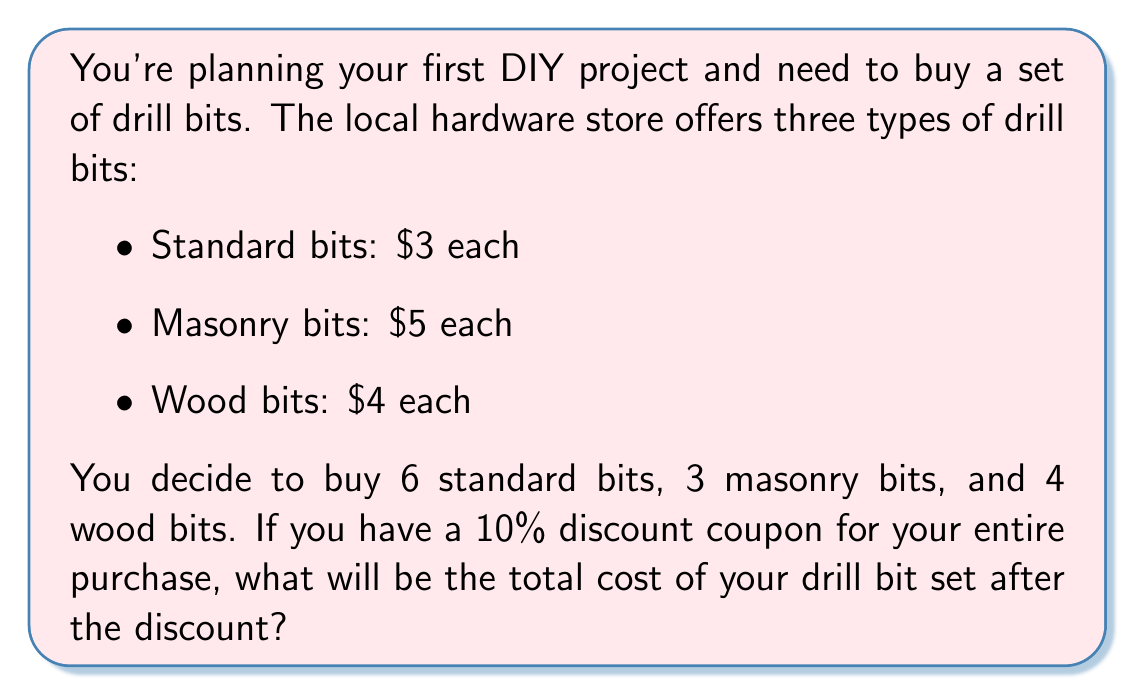Solve this math problem. Let's approach this step-by-step:

1) First, let's calculate the cost of each type of drill bit:
   - Standard bits: $6 \times $3 = $18$
   - Masonry bits: $3 \times $5 = $15$
   - Wood bits: $4 \times $4 = $16$

2) Now, let's add up the total cost before the discount:
   $$18 + 15 + 16 = $49$$

3) The 10% discount means we need to subtract 10% of the total from the price.
   To calculate 10%, we multiply by 0.10:
   $$49 \times 0.10 = $4.90$$

4) Now, we subtract this discount from the original price:
   $$49 - 4.90 = $44.10$$

Therefore, the total cost after the 10% discount is $44.10.
Answer: $44.10 